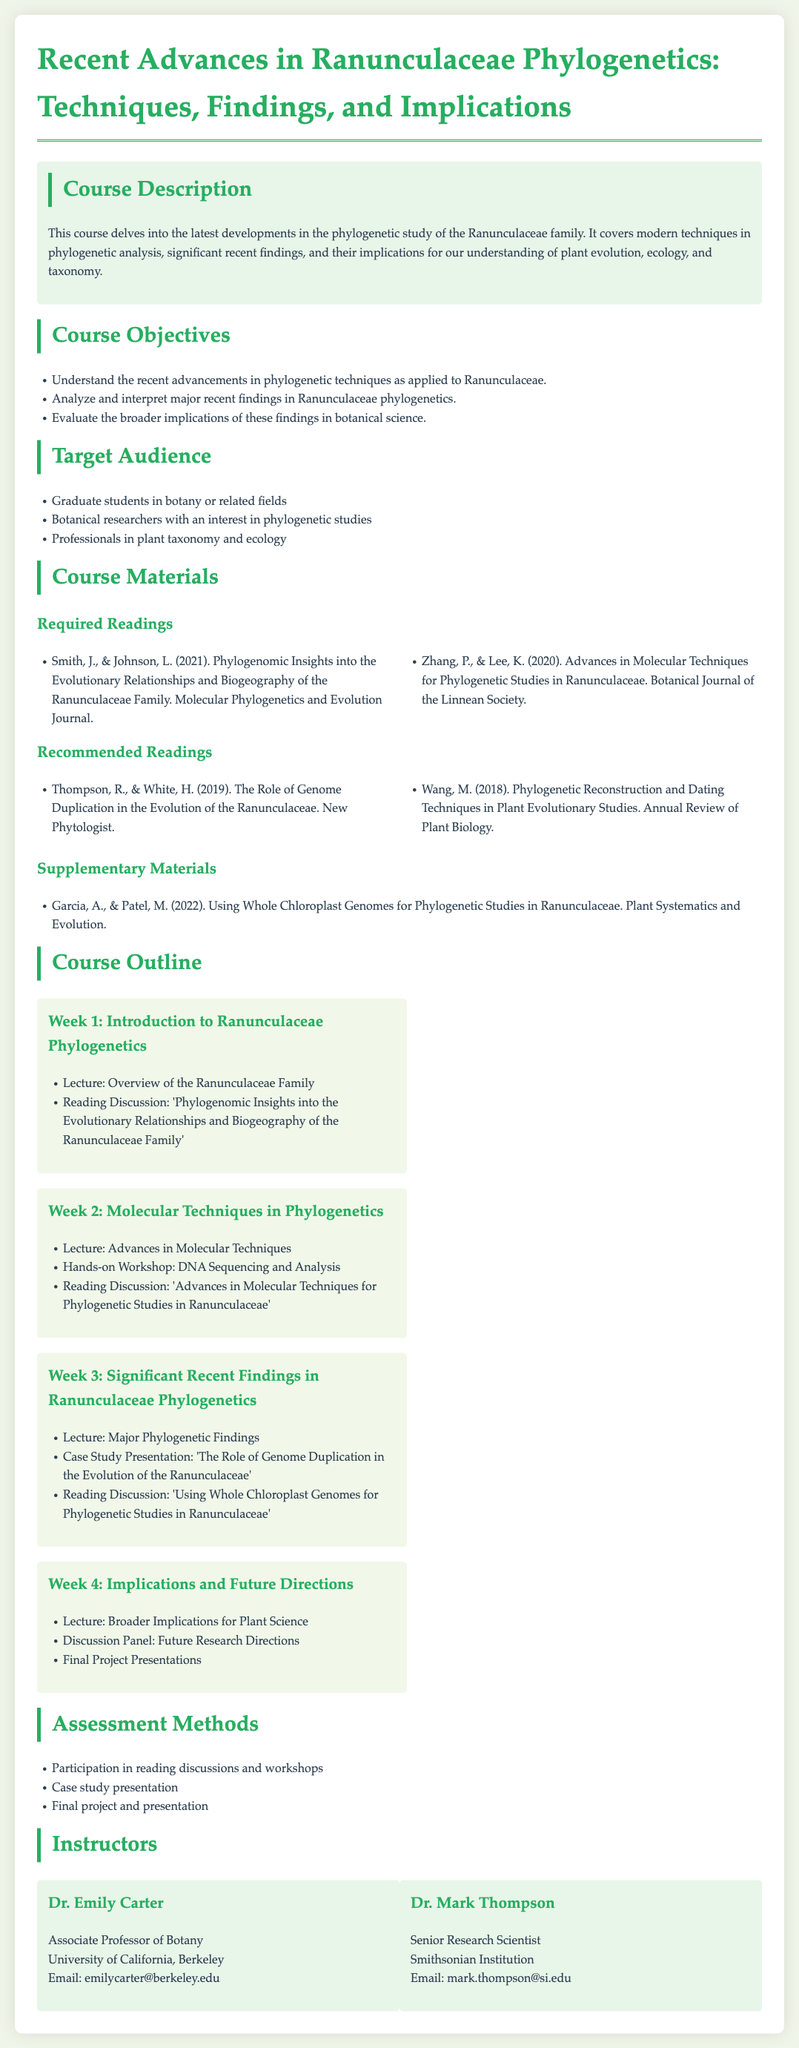What is the course title? The course title is explicitly stated at the beginning of the document.
Answer: Recent Advances in Ranunculaceae Phylogenetics: Techniques, Findings, and Implications Who are the instructors of the course? The document lists two instructors under the section "Instructors".
Answer: Dr. Emily Carter and Dr. Mark Thompson What is the target audience for the course? The document specifies the target audience in a bulleted list.
Answer: Graduate students in botany or related fields, botanical researchers, and professionals in plant taxonomy and ecology What is the main focus of Week 3? The week and its focus are clearly outlined in the course outline section of the document.
Answer: Significant Recent Findings in Ranunculaceae Phylogenetics How many required readings are listed? By counting the items in the "Required Readings" section, the total is determined.
Answer: 2 What topic is covered in Week 4's lecture? The document lists the topics for each week, and this can be found under Week 4.
Answer: Broader Implications for Plant Science How many assessment methods are mentioned? The document lists the assessment methods in a bulleted format, providing a total count.
Answer: 3 